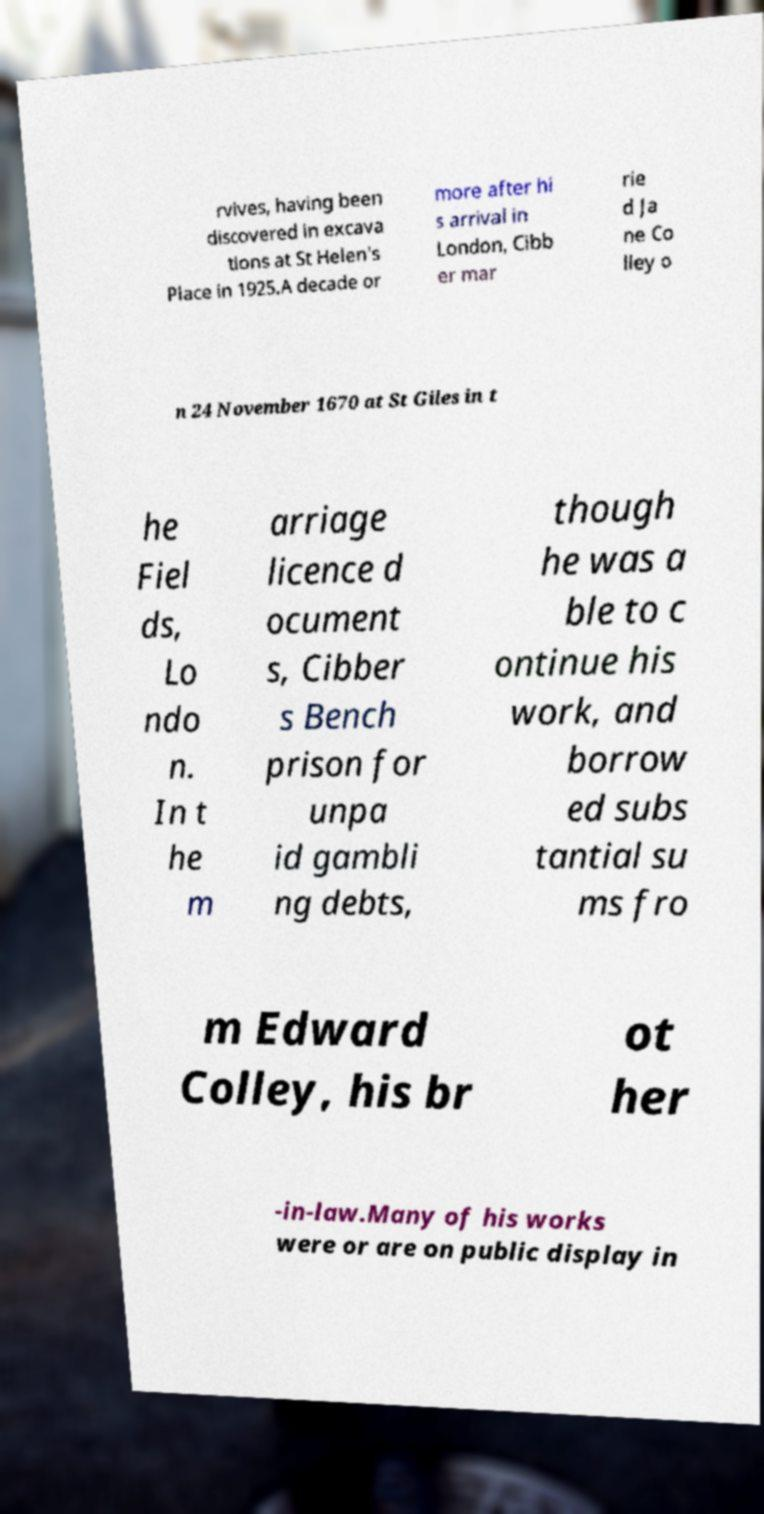Please read and relay the text visible in this image. What does it say? rvives, having been discovered in excava tions at St Helen's Place in 1925.A decade or more after hi s arrival in London, Cibb er mar rie d Ja ne Co lley o n 24 November 1670 at St Giles in t he Fiel ds, Lo ndo n. In t he m arriage licence d ocument s, Cibber s Bench prison for unpa id gambli ng debts, though he was a ble to c ontinue his work, and borrow ed subs tantial su ms fro m Edward Colley, his br ot her -in-law.Many of his works were or are on public display in 